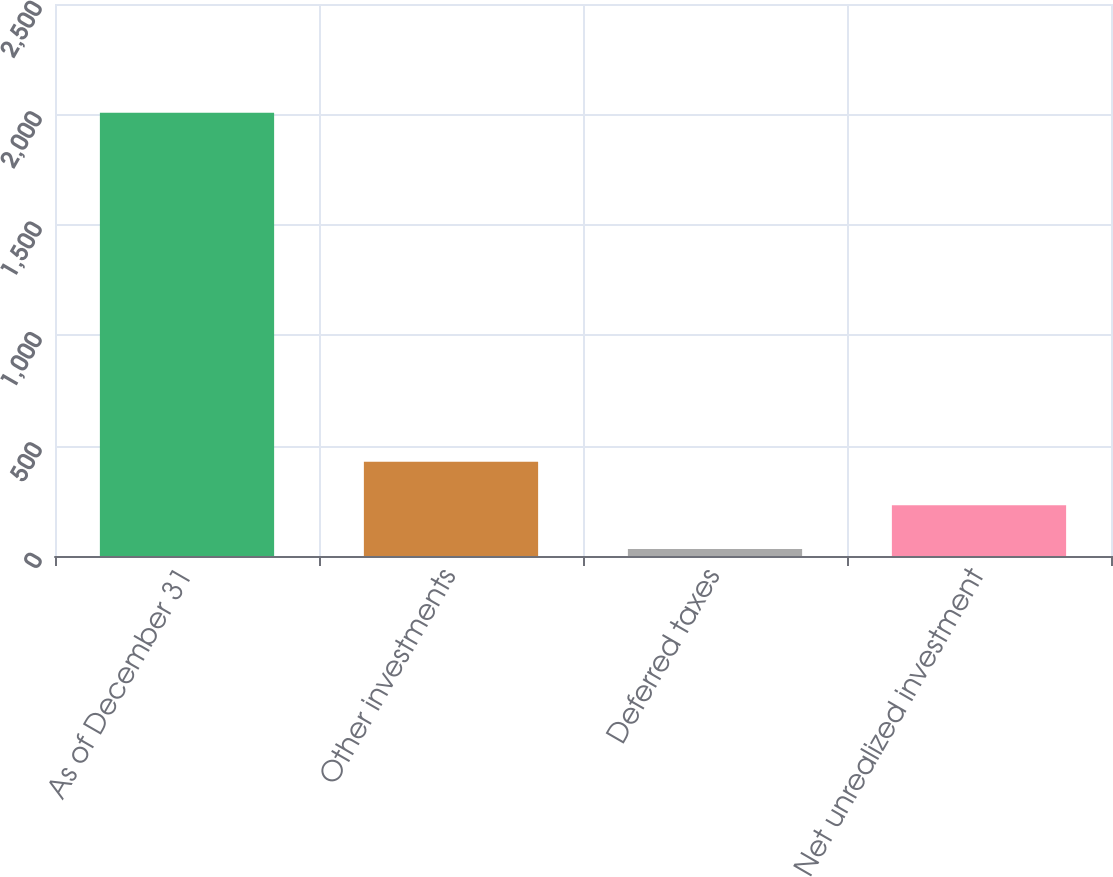Convert chart. <chart><loc_0><loc_0><loc_500><loc_500><bar_chart><fcel>As of December 31<fcel>Other investments<fcel>Deferred taxes<fcel>Net unrealized investment<nl><fcel>2008<fcel>427.2<fcel>32<fcel>229.6<nl></chart> 